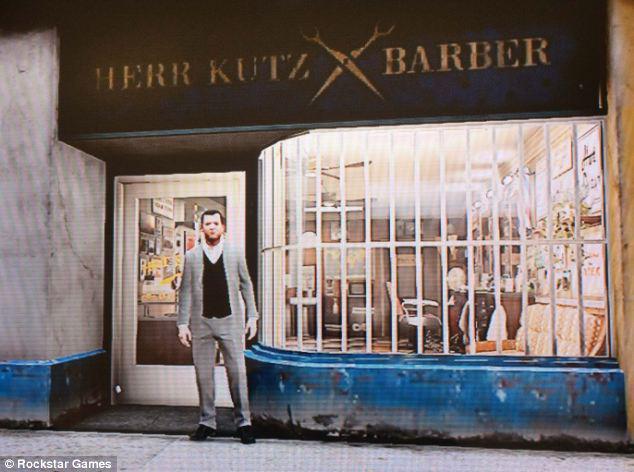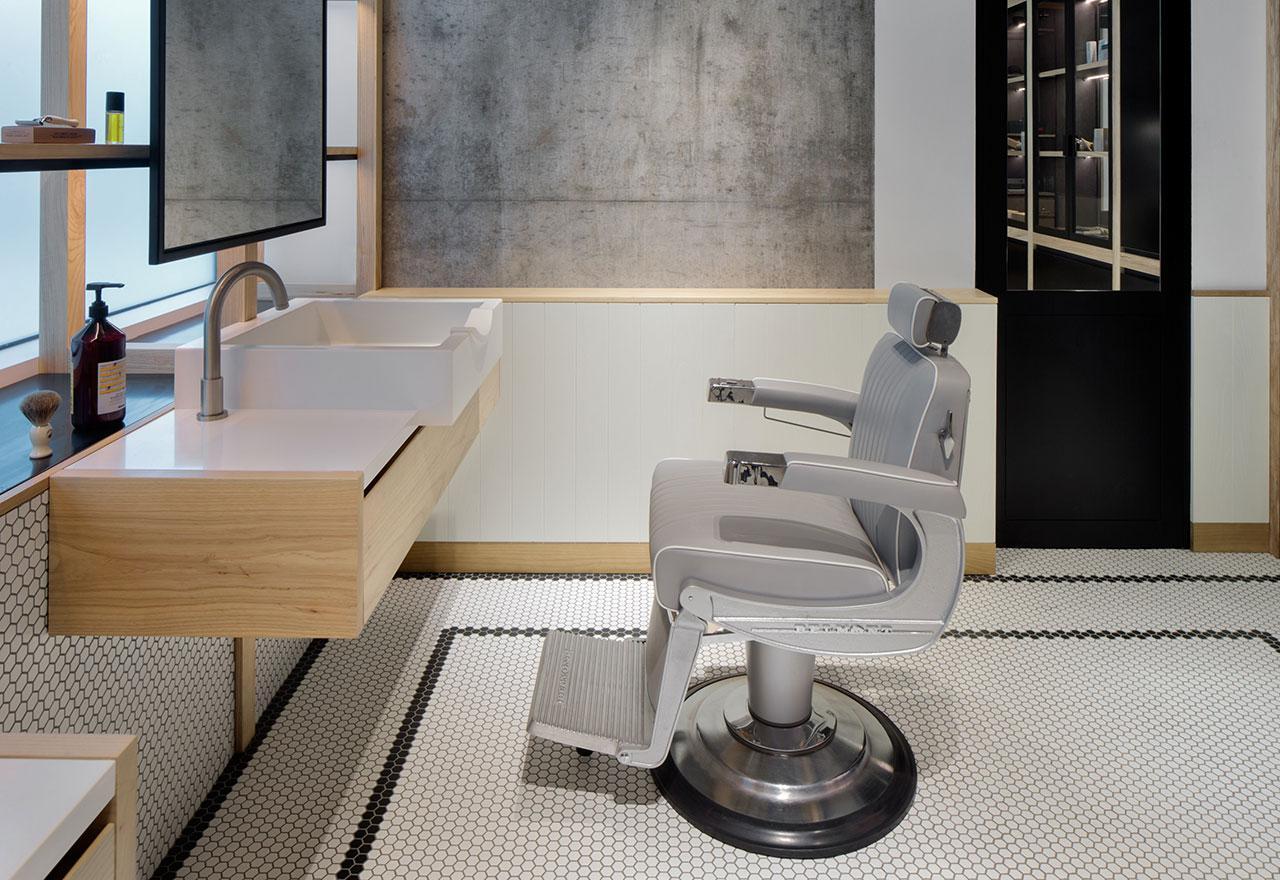The first image is the image on the left, the second image is the image on the right. For the images displayed, is the sentence "An image shows a black female barber holding scissors and standing behind a forward-facing male with his hands on armrests." factually correct? Answer yes or no. No. The first image is the image on the left, the second image is the image on the right. Evaluate the accuracy of this statement regarding the images: "One picture contains a man with short hair and facial hair getting his hair cut by an African American woman.". Is it true? Answer yes or no. No. 